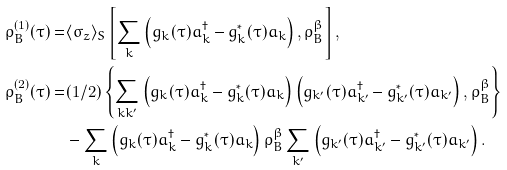Convert formula to latex. <formula><loc_0><loc_0><loc_500><loc_500>\varrho ^ { ( 1 ) } _ { B } ( \tau ) = & \langle \sigma _ { z } \rangle _ { S } \left [ \sum _ { k } \left ( g _ { k } ( \tau ) a ^ { \dag } _ { k } - g ^ { * } _ { k } ( \tau ) a _ { k } \right ) , \varrho _ { B } ^ { \beta } \right ] , \\ \varrho ^ { ( 2 ) } _ { B } ( \tau ) = & ( 1 / 2 ) \left \{ \sum _ { k k ^ { \prime } } \left ( g _ { k } ( \tau ) a ^ { \dag } _ { k } - g ^ { * } _ { k } ( \tau ) a _ { k } \right ) \left ( g _ { k ^ { \prime } } ( \tau ) a ^ { \dag } _ { k ^ { \prime } } - g ^ { * } _ { k ^ { \prime } } ( \tau ) a _ { k ^ { \prime } } \right ) , \varrho _ { B } ^ { \beta } \right \} \\ & - \sum _ { k } \left ( g _ { k } ( \tau ) a ^ { \dag } _ { k } - g ^ { * } _ { k } ( \tau ) a _ { k } \right ) \varrho _ { B } ^ { \beta } \sum _ { k ^ { \prime } } \left ( g _ { k ^ { \prime } } ( \tau ) a ^ { \dag } _ { k ^ { \prime } } - g ^ { * } _ { k ^ { \prime } } ( \tau ) a _ { k ^ { \prime } } \right ) .</formula> 